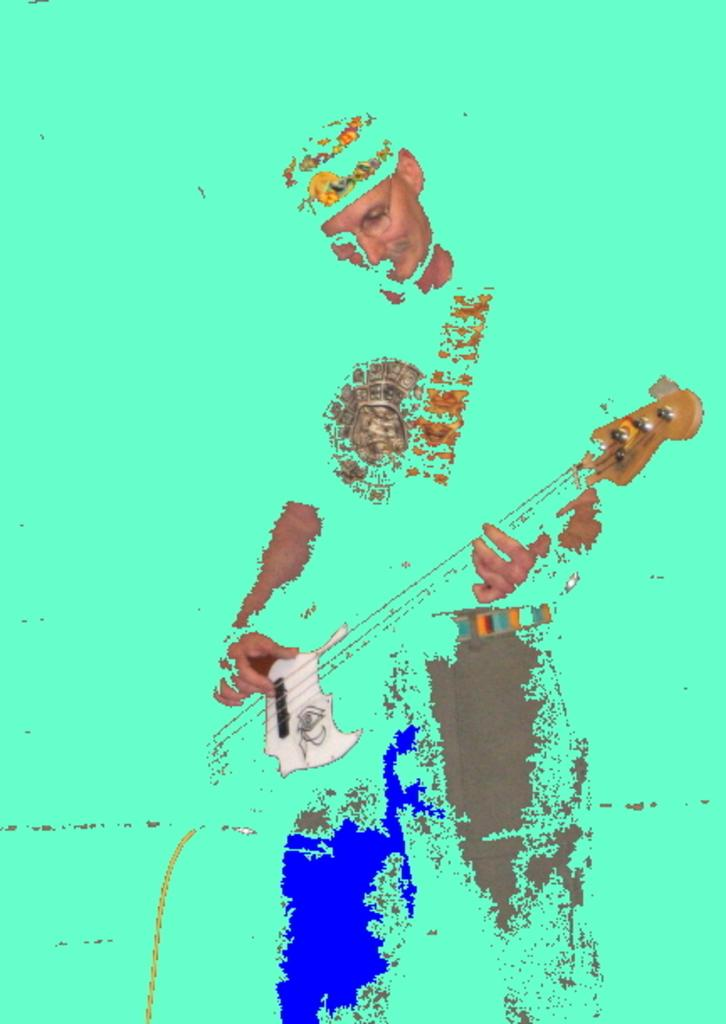What is the main subject of the image? There is a person in the image. What is the person doing in the image? The person is playing a guitar. What color is the background of the image? The background of the image is green. What type of drink is the person holding in the image? There is no drink visible in the image; the person is playing a guitar. How does the person's growth affect the guitar playing in the image? There is no information about the person's growth in the image, and it does not affect the guitar playing. 